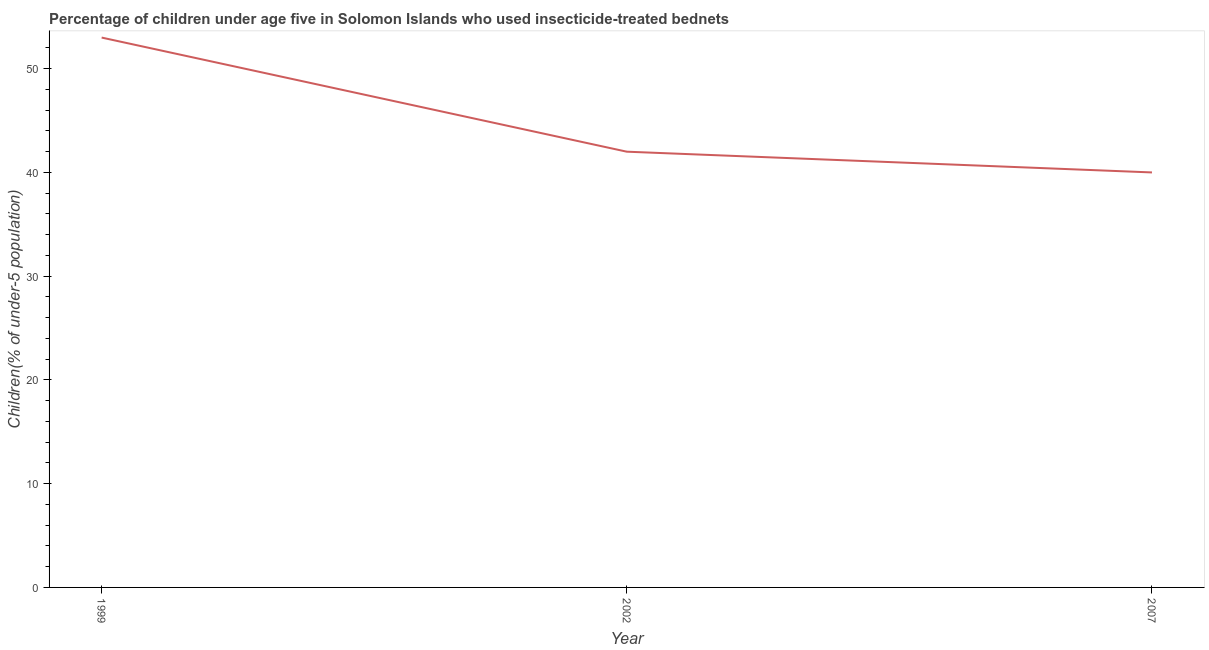What is the percentage of children who use of insecticide-treated bed nets in 2007?
Offer a very short reply. 40. Across all years, what is the maximum percentage of children who use of insecticide-treated bed nets?
Give a very brief answer. 53. Across all years, what is the minimum percentage of children who use of insecticide-treated bed nets?
Make the answer very short. 40. In which year was the percentage of children who use of insecticide-treated bed nets maximum?
Ensure brevity in your answer.  1999. What is the sum of the percentage of children who use of insecticide-treated bed nets?
Make the answer very short. 135. What is the difference between the percentage of children who use of insecticide-treated bed nets in 2002 and 2007?
Your response must be concise. 2. What is the median percentage of children who use of insecticide-treated bed nets?
Offer a very short reply. 42. What is the ratio of the percentage of children who use of insecticide-treated bed nets in 1999 to that in 2007?
Keep it short and to the point. 1.32. What is the difference between the highest and the lowest percentage of children who use of insecticide-treated bed nets?
Offer a terse response. 13. In how many years, is the percentage of children who use of insecticide-treated bed nets greater than the average percentage of children who use of insecticide-treated bed nets taken over all years?
Provide a succinct answer. 1. How many years are there in the graph?
Ensure brevity in your answer.  3. What is the difference between two consecutive major ticks on the Y-axis?
Provide a succinct answer. 10. Does the graph contain grids?
Provide a succinct answer. No. What is the title of the graph?
Offer a terse response. Percentage of children under age five in Solomon Islands who used insecticide-treated bednets. What is the label or title of the Y-axis?
Your answer should be very brief. Children(% of under-5 population). What is the Children(% of under-5 population) in 1999?
Your response must be concise. 53. What is the Children(% of under-5 population) in 2007?
Ensure brevity in your answer.  40. What is the difference between the Children(% of under-5 population) in 1999 and 2007?
Provide a succinct answer. 13. What is the difference between the Children(% of under-5 population) in 2002 and 2007?
Offer a very short reply. 2. What is the ratio of the Children(% of under-5 population) in 1999 to that in 2002?
Give a very brief answer. 1.26. What is the ratio of the Children(% of under-5 population) in 1999 to that in 2007?
Make the answer very short. 1.32. 